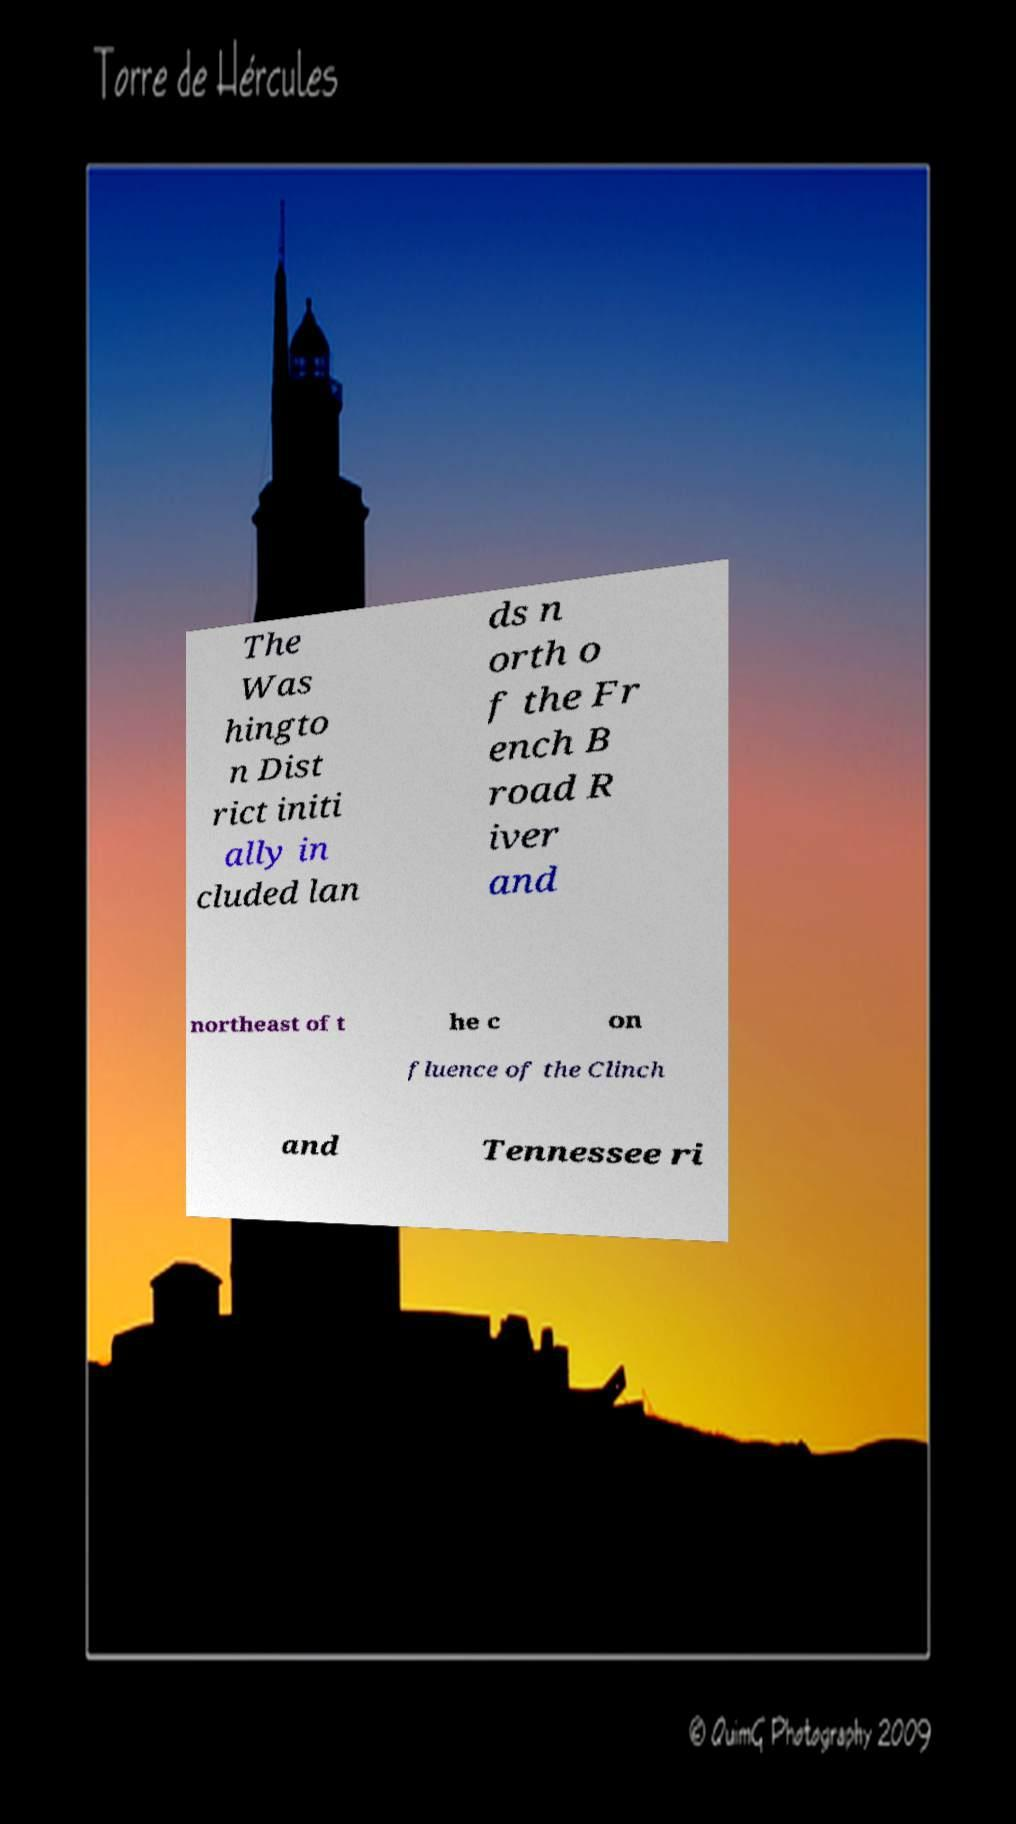I need the written content from this picture converted into text. Can you do that? The Was hingto n Dist rict initi ally in cluded lan ds n orth o f the Fr ench B road R iver and northeast of t he c on fluence of the Clinch and Tennessee ri 